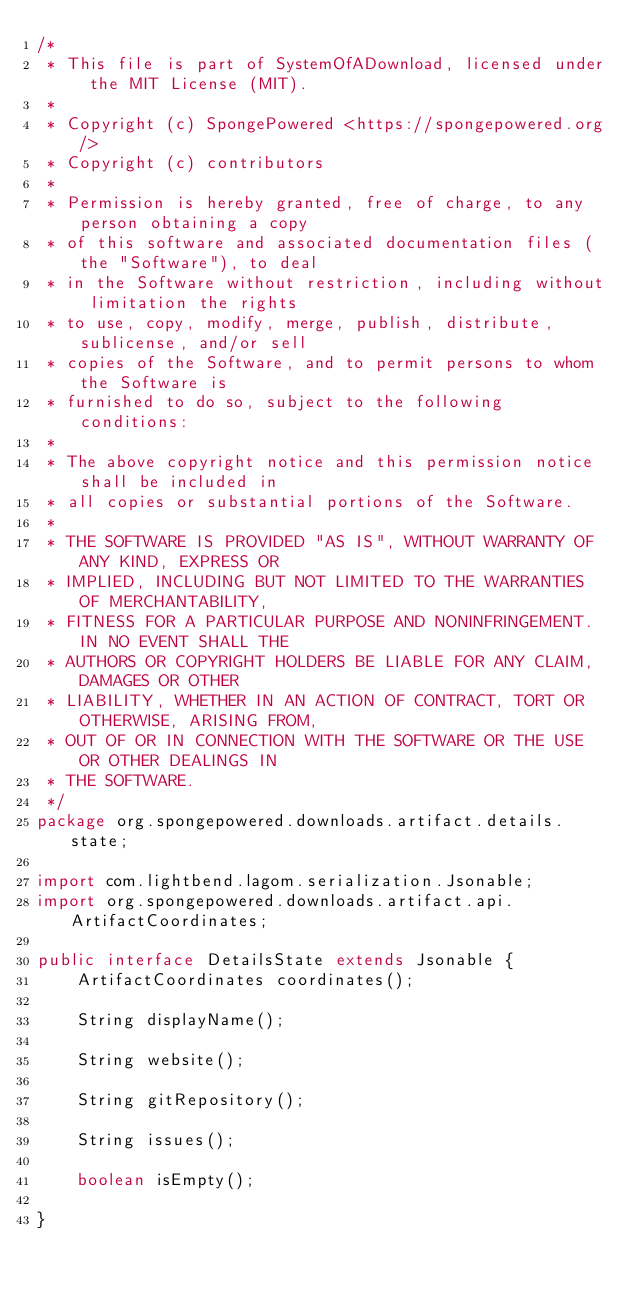<code> <loc_0><loc_0><loc_500><loc_500><_Java_>/*
 * This file is part of SystemOfADownload, licensed under the MIT License (MIT).
 *
 * Copyright (c) SpongePowered <https://spongepowered.org/>
 * Copyright (c) contributors
 *
 * Permission is hereby granted, free of charge, to any person obtaining a copy
 * of this software and associated documentation files (the "Software"), to deal
 * in the Software without restriction, including without limitation the rights
 * to use, copy, modify, merge, publish, distribute, sublicense, and/or sell
 * copies of the Software, and to permit persons to whom the Software is
 * furnished to do so, subject to the following conditions:
 *
 * The above copyright notice and this permission notice shall be included in
 * all copies or substantial portions of the Software.
 *
 * THE SOFTWARE IS PROVIDED "AS IS", WITHOUT WARRANTY OF ANY KIND, EXPRESS OR
 * IMPLIED, INCLUDING BUT NOT LIMITED TO THE WARRANTIES OF MERCHANTABILITY,
 * FITNESS FOR A PARTICULAR PURPOSE AND NONINFRINGEMENT. IN NO EVENT SHALL THE
 * AUTHORS OR COPYRIGHT HOLDERS BE LIABLE FOR ANY CLAIM, DAMAGES OR OTHER
 * LIABILITY, WHETHER IN AN ACTION OF CONTRACT, TORT OR OTHERWISE, ARISING FROM,
 * OUT OF OR IN CONNECTION WITH THE SOFTWARE OR THE USE OR OTHER DEALINGS IN
 * THE SOFTWARE.
 */
package org.spongepowered.downloads.artifact.details.state;

import com.lightbend.lagom.serialization.Jsonable;
import org.spongepowered.downloads.artifact.api.ArtifactCoordinates;

public interface DetailsState extends Jsonable {
    ArtifactCoordinates coordinates();

    String displayName();

    String website();

    String gitRepository();

    String issues();

    boolean isEmpty();

}
</code> 